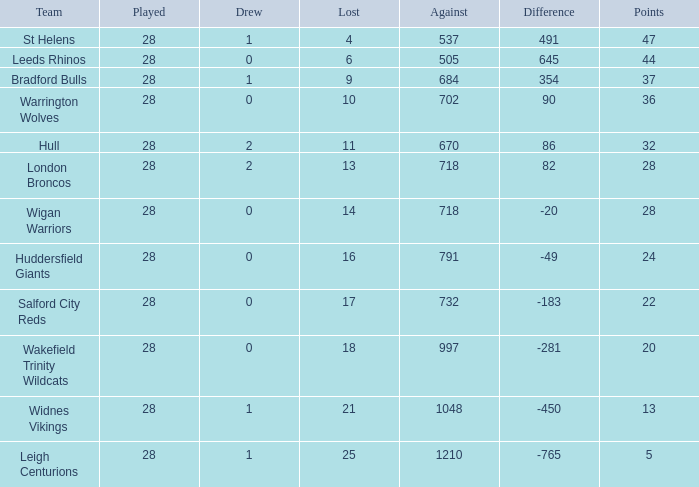What is the maximum difference for a team with fewer than 0 draws? None. 